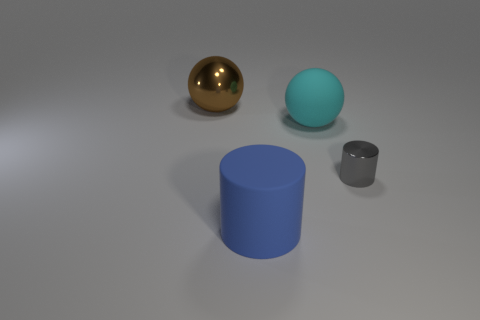Is the number of cyan objects on the left side of the brown ball greater than the number of yellow rubber spheres?
Your response must be concise. No. There is a tiny shiny object; is its shape the same as the big blue object to the left of the cyan rubber ball?
Keep it short and to the point. Yes. How many matte spheres are the same size as the blue matte thing?
Offer a very short reply. 1. There is a big sphere left of the big ball in front of the brown thing; how many small gray cylinders are to the left of it?
Provide a succinct answer. 0. Are there an equal number of cylinders right of the big cyan rubber object and large brown shiny balls that are in front of the blue matte object?
Offer a terse response. No. What number of tiny objects have the same shape as the big blue thing?
Make the answer very short. 1. Is there a yellow cylinder that has the same material as the cyan thing?
Make the answer very short. No. How many large blue matte things are there?
Offer a very short reply. 1. What number of cylinders are large things or big brown metal things?
Keep it short and to the point. 1. There is a shiny sphere that is the same size as the blue thing; what color is it?
Offer a terse response. Brown. 